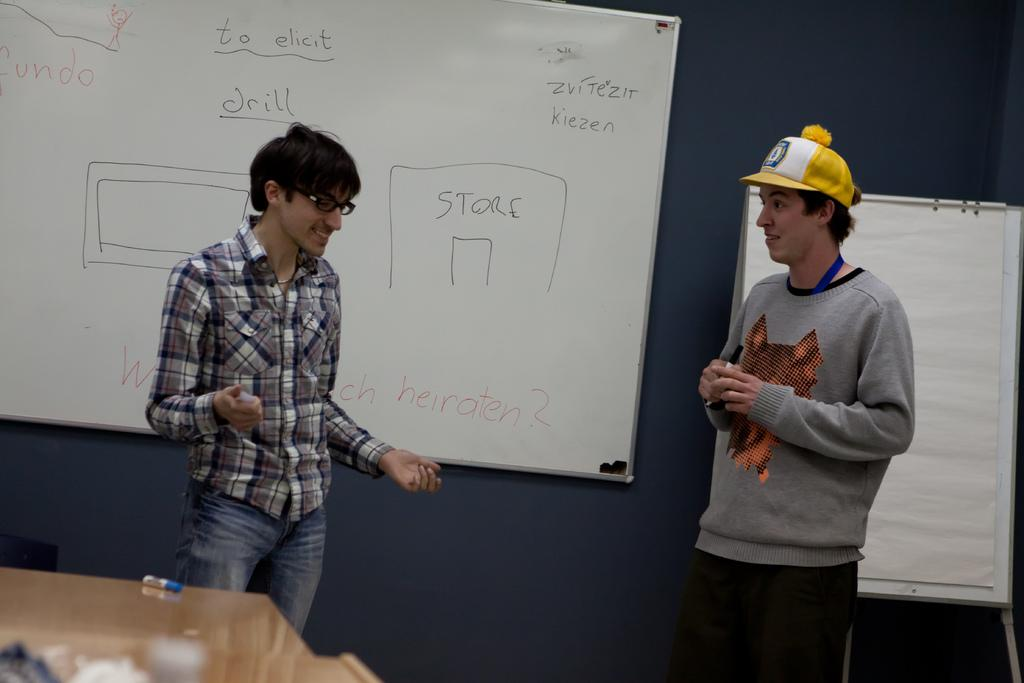Provide a one-sentence caption for the provided image. Two students give a presentation in front of a dry erase board with a Store drawn on it. 